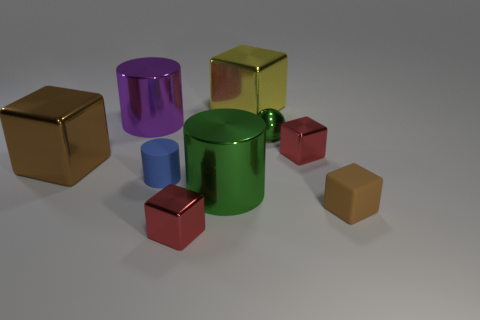What is the color of the tiny cylinder to the left of the yellow metal block?
Give a very brief answer. Blue. What number of other things are the same material as the big brown block?
Your answer should be very brief. 6. Is the number of large cylinders that are in front of the green metallic ball greater than the number of blue rubber cylinders in front of the brown matte object?
Your answer should be compact. Yes. How many rubber blocks are on the right side of the purple metal cylinder?
Offer a terse response. 1. Are the purple thing and the tiny blue object in front of the sphere made of the same material?
Provide a succinct answer. No. Is there anything else that is the same shape as the small green metallic thing?
Your response must be concise. No. Does the small blue cylinder have the same material as the large yellow cube?
Offer a terse response. No. Is there a blue thing that is in front of the red metal cube behind the matte cube?
Ensure brevity in your answer.  Yes. How many cubes are both to the right of the rubber cylinder and in front of the purple cylinder?
Keep it short and to the point. 3. There is a brown thing that is behind the tiny rubber block; what is its shape?
Your answer should be very brief. Cube. 